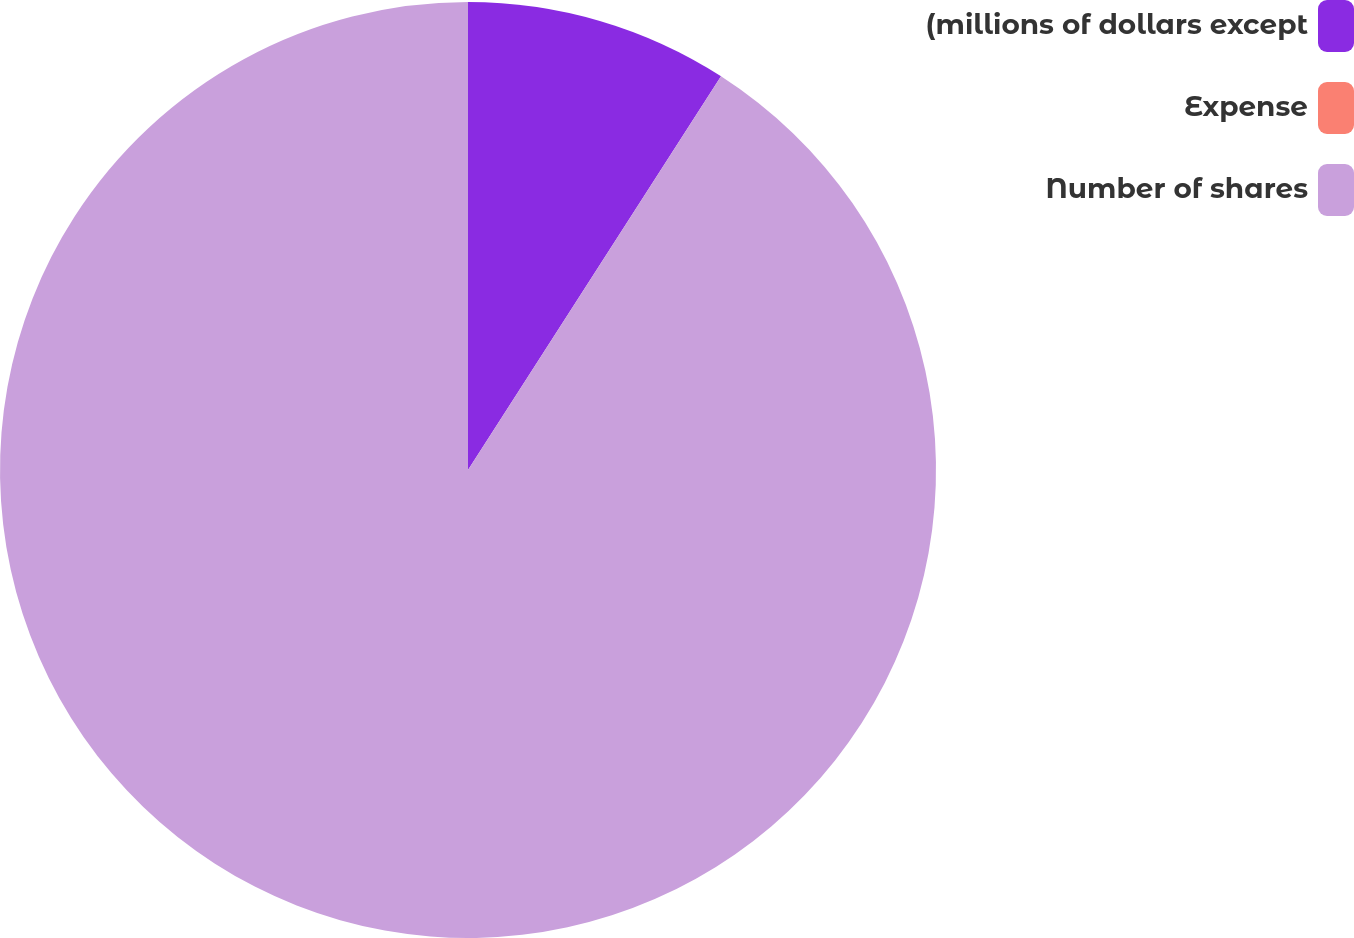<chart> <loc_0><loc_0><loc_500><loc_500><pie_chart><fcel>(millions of dollars except<fcel>Expense<fcel>Number of shares<nl><fcel>9.09%<fcel>0.0%<fcel>90.9%<nl></chart> 